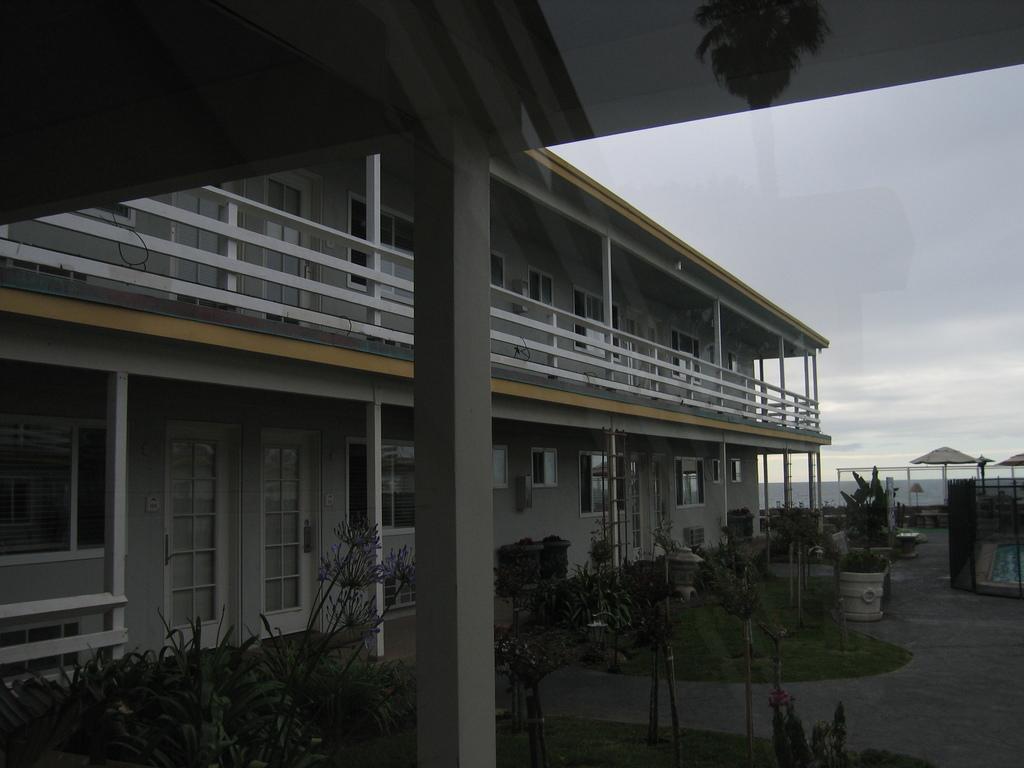Could you give a brief overview of what you see in this image? In this picture I can observe a building. There are some plants on the ground. In the background I can observe some clouds in the sky. 